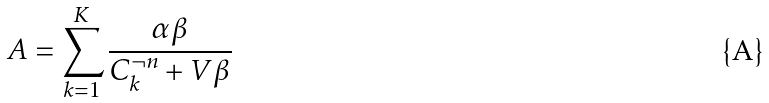Convert formula to latex. <formula><loc_0><loc_0><loc_500><loc_500>A = \sum _ { k = 1 } ^ { K } \frac { \alpha \beta } { C _ { k } ^ { \neg n } + V \beta }</formula> 